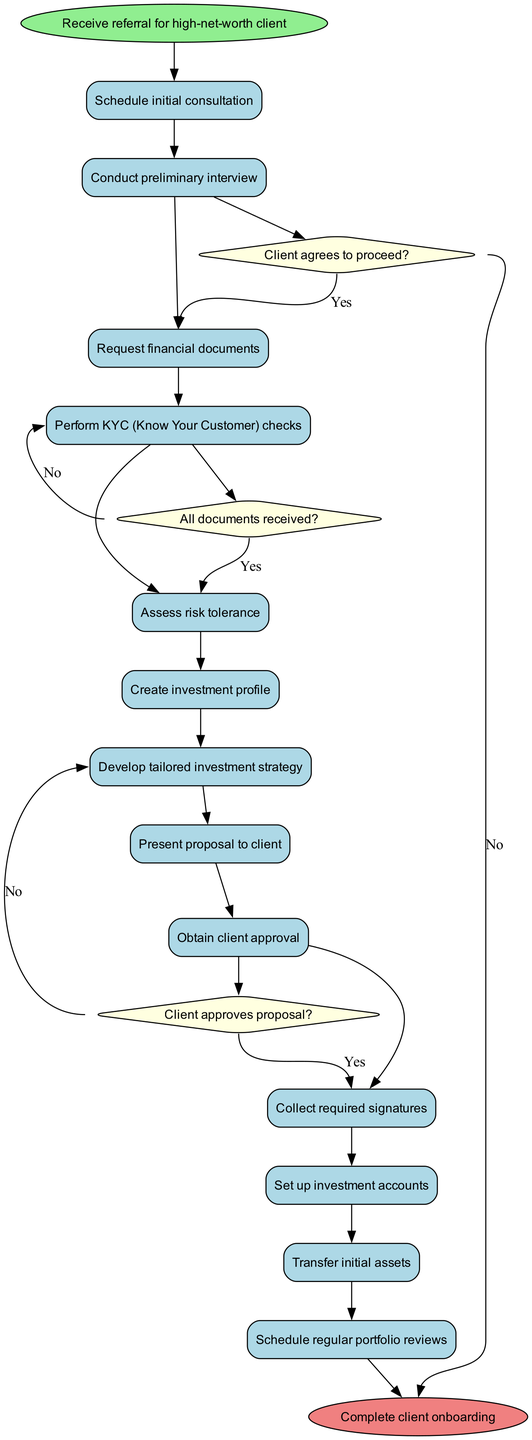What is the starting node in the diagram? The starting node is indicated at the top of the diagram and is labeled "Receive referral for high-net-worth client."
Answer: Receive referral for high-net-worth client How many activities are listed in the diagram? By counting the activities within the "activities" section of the diagram, there are a total of 12 activities mentioned.
Answer: 12 What happens after the preliminary interview? According to the flow of the diagram, after the preliminary interview, the next step is to pose the question, "Client agrees to proceed?"
Answer: Ask if client agrees to proceed What is the last activity before completing client onboarding? The activity just before reaching the end node ("Complete client onboarding") is transferring the initial assets, based on the sequence outlined in the activities.
Answer: Transfer initial assets If the client does not approve the proposal, what is the next step? If the client does not approve the proposal, according to the decision node, the process requires revising the investment strategy, as indicated in the decision flow.
Answer: Revise investment strategy What happens if all documents are not received? If not all documents are received, the diagram shows that the next action is to follow up on missing documents, thus indicating the need to check document completeness.
Answer: Follow up on missing documents How many decision nodes are present in the diagram? The diagram contains three decision nodes, which are questions that determine the flow of the onboarding process based on client responses.
Answer: 3 What are the outcomes of the decision node that asks "Client agrees to proceed?" The outcomes of this decision node are twofold: if the client agrees, the process continues to request financial documents; if the client does not agree, the process ends.
Answer: Request financial documents or End process 